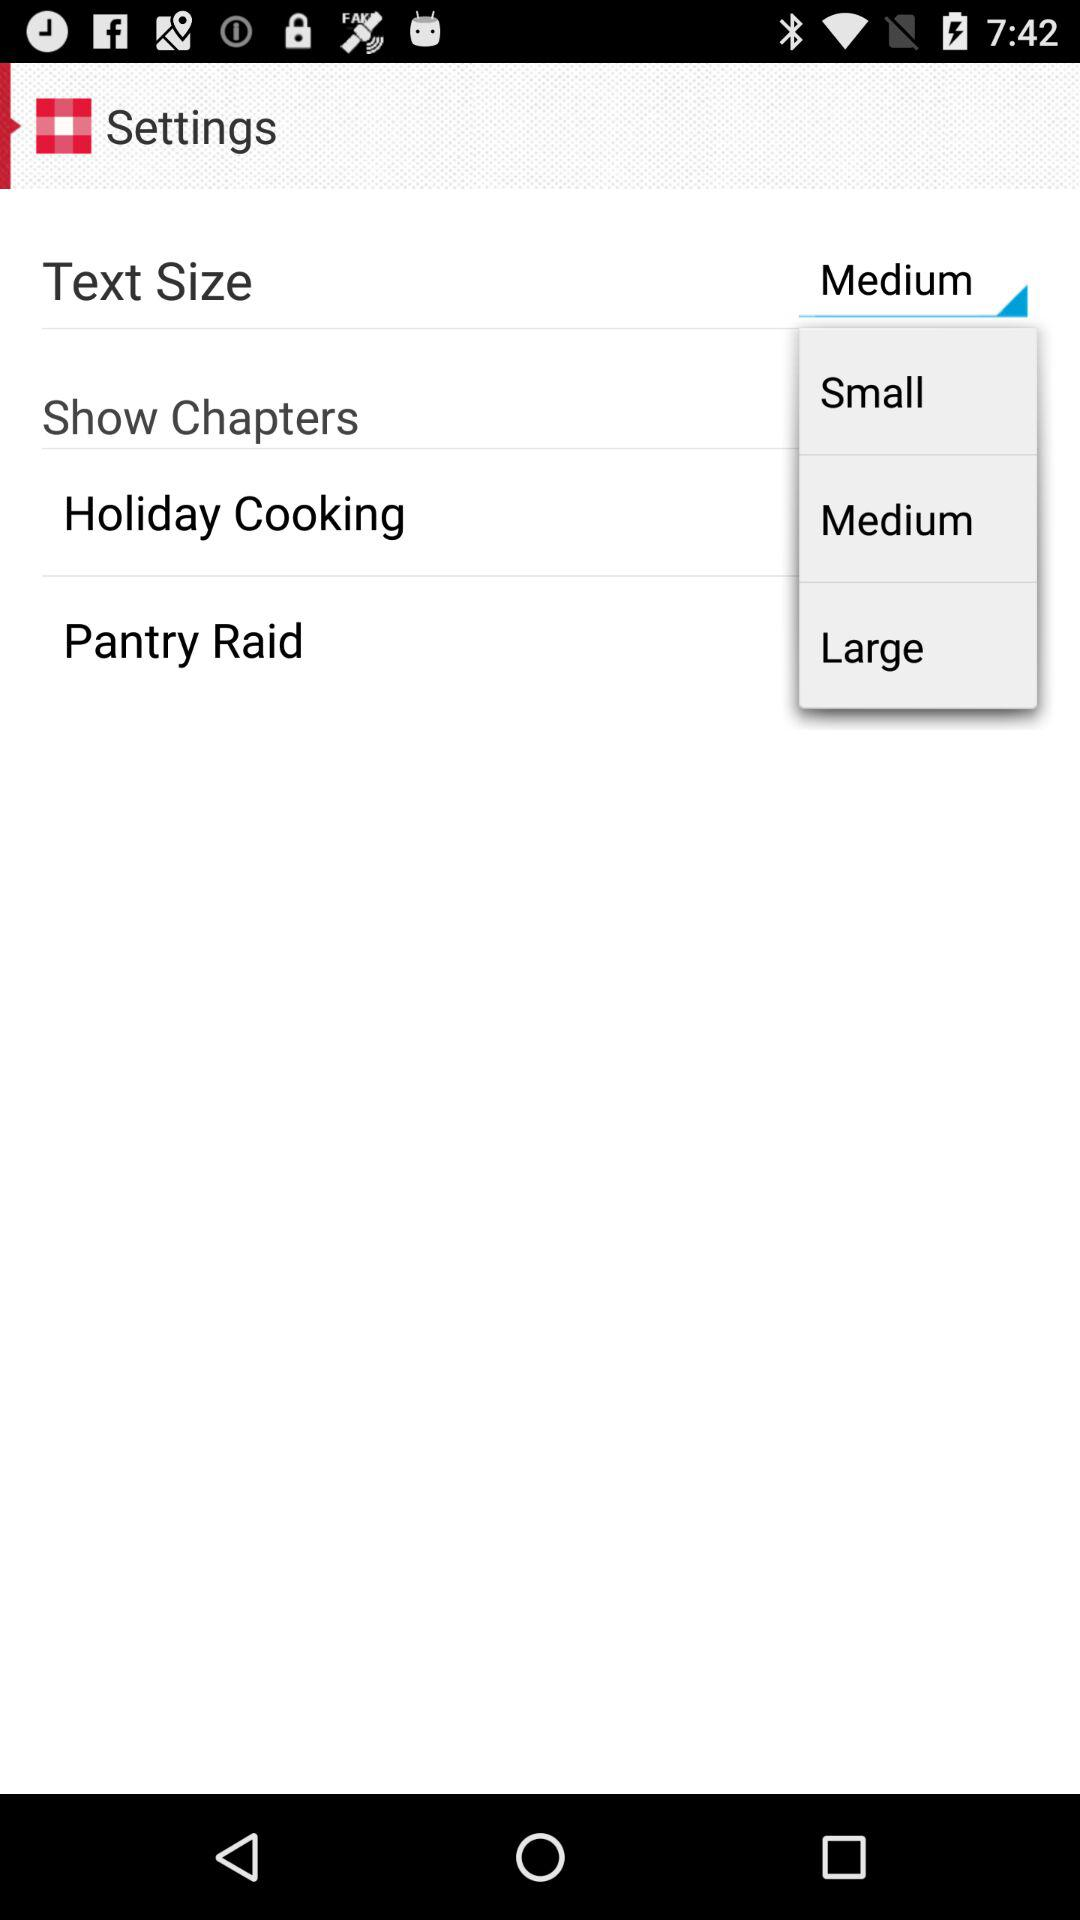What is the selected text size? The selected text size is medium. 